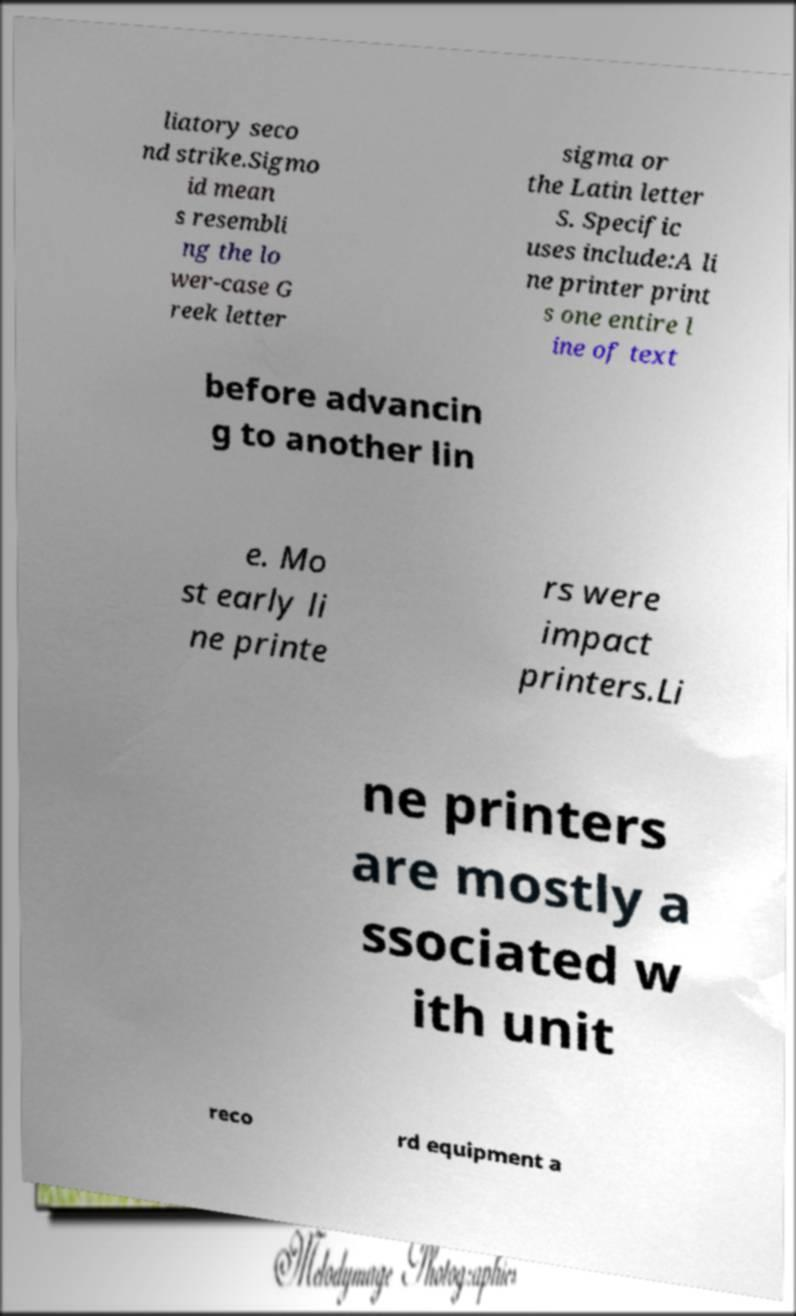Please identify and transcribe the text found in this image. liatory seco nd strike.Sigmo id mean s resembli ng the lo wer-case G reek letter sigma or the Latin letter S. Specific uses include:A li ne printer print s one entire l ine of text before advancin g to another lin e. Mo st early li ne printe rs were impact printers.Li ne printers are mostly a ssociated w ith unit reco rd equipment a 